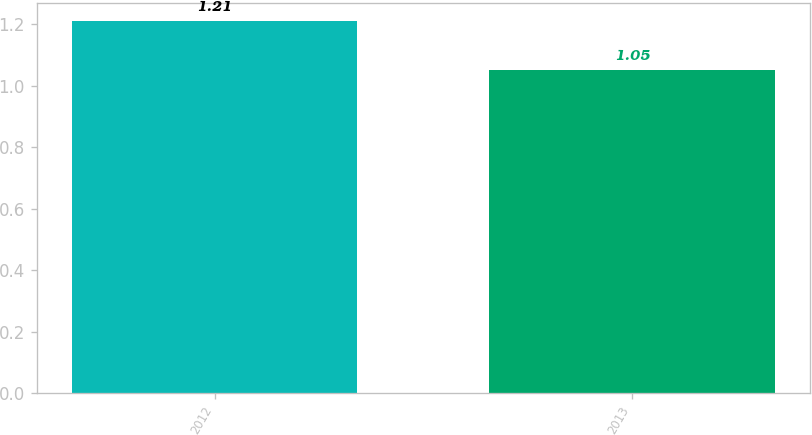Convert chart. <chart><loc_0><loc_0><loc_500><loc_500><bar_chart><fcel>2012<fcel>2013<nl><fcel>1.21<fcel>1.05<nl></chart> 